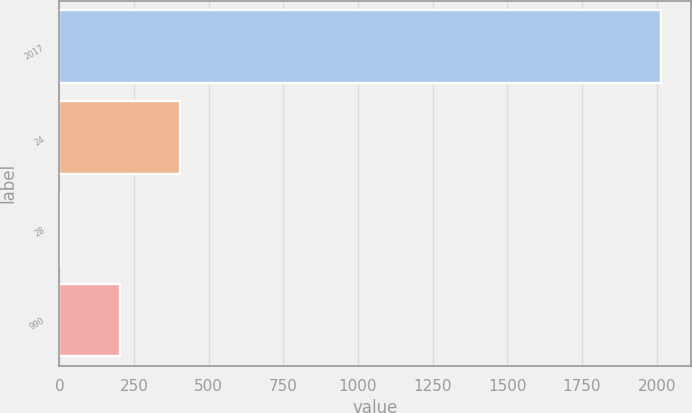Convert chart. <chart><loc_0><loc_0><loc_500><loc_500><bar_chart><fcel>2017<fcel>24<fcel>28<fcel>990<nl><fcel>2015<fcel>404.6<fcel>2<fcel>203.3<nl></chart> 